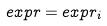<formula> <loc_0><loc_0><loc_500><loc_500>e x p r = e x p r _ { i }</formula> 